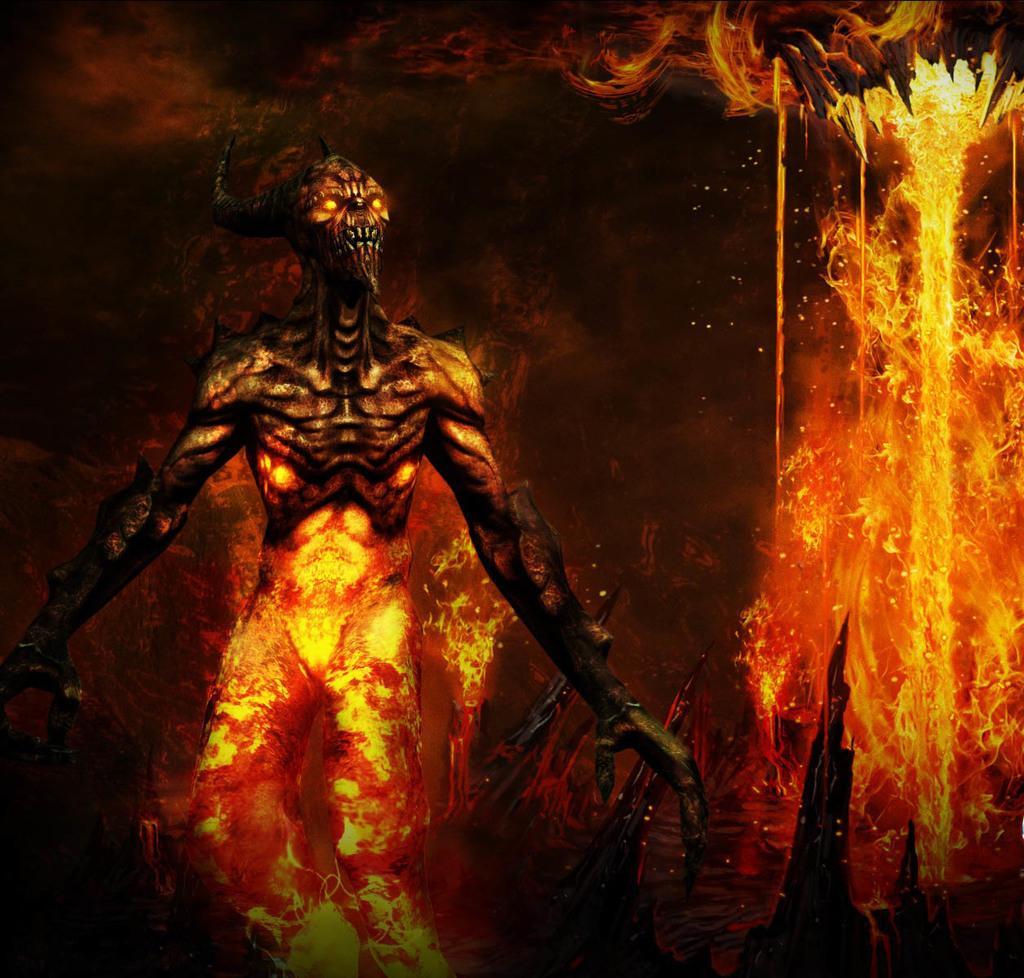In one or two sentences, can you explain what this image depicts? In the image we can see the animated picture. 